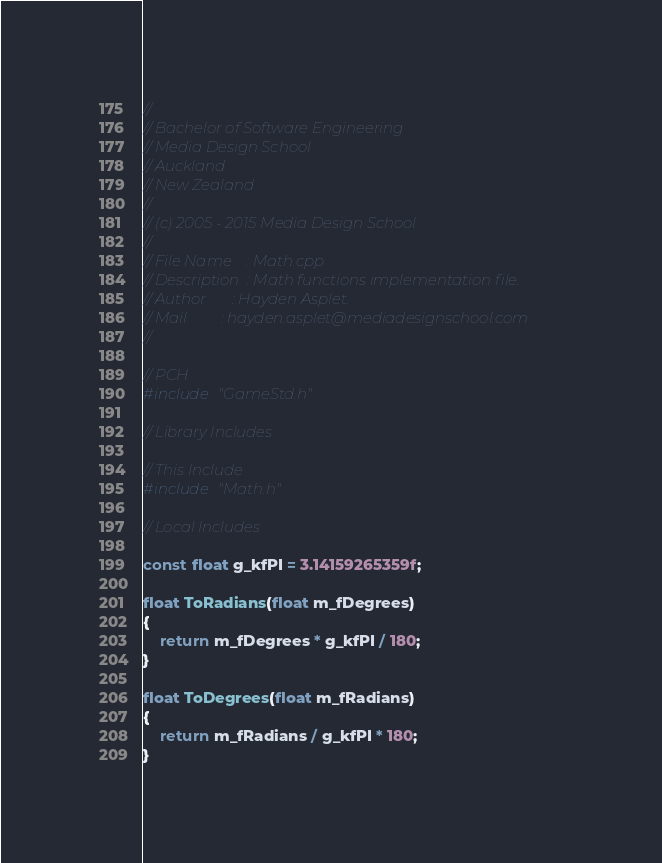<code> <loc_0><loc_0><loc_500><loc_500><_C++_>// 
// Bachelor of Software Engineering
// Media Design School
// Auckland
// New Zealand
//
// (c) 2005 - 2015 Media Design School
//
// File Name	: Math.cpp
// Description	: Math functions implementation file.
// Author		: Hayden Asplet.
// Mail			: hayden.asplet@mediadesignschool.com
//

// PCH
#include "GameStd.h"

// Library Includes

// This Include
#include "Math.h"

// Local Includes

const float g_kfPI = 3.14159265359f;

float ToRadians(float m_fDegrees)
{
	return m_fDegrees * g_kfPI / 180;
}

float ToDegrees(float m_fRadians)
{
	return m_fRadians / g_kfPI * 180;
}
</code> 